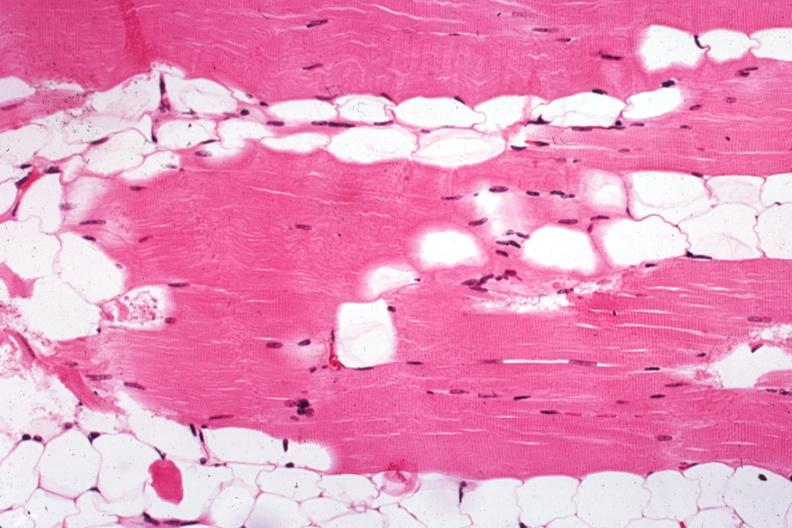what does this image show?
Answer the question using a single word or phrase. Excellent example case of myasthenia gravis treated 